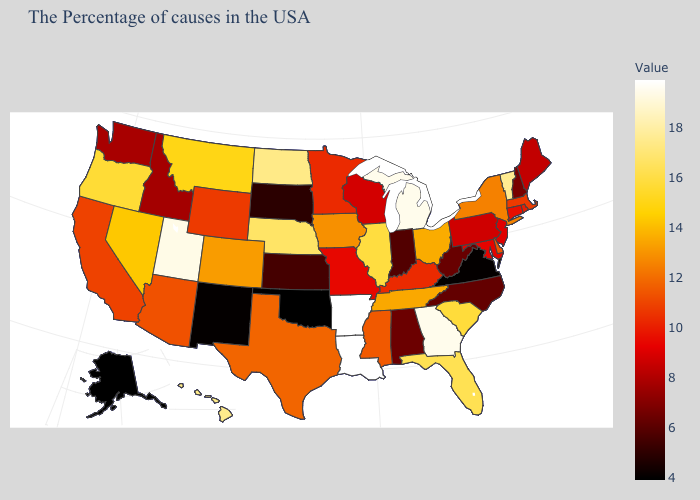Is the legend a continuous bar?
Quick response, please. Yes. 